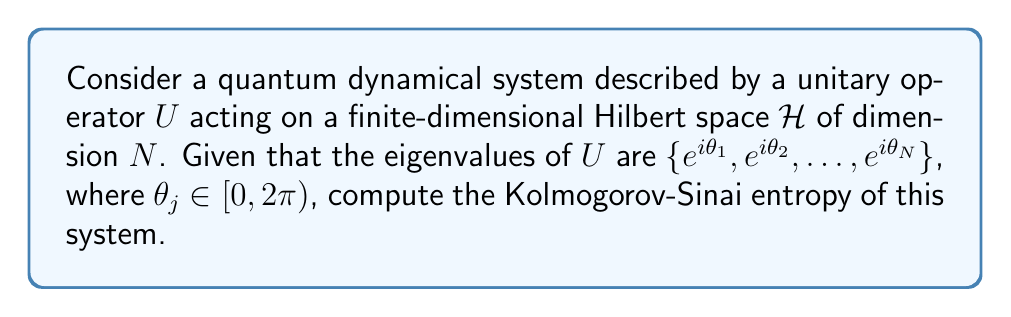Could you help me with this problem? To compute the Kolmogorov-Sinai entropy for this quantum dynamical system, we'll follow these steps:

1) In quantum systems, the Kolmogorov-Sinai entropy is related to the von Neumann entropy rate of the system.

2) For a unitary quantum evolution, the von Neumann entropy of the system remains constant over time. Therefore, the entropy rate (and thus the Kolmogorov-Sinai entropy) is zero for closed quantum systems.

3) This can be understood from the fact that unitary evolution preserves the eigenvalues of the density matrix, and thus the von Neumann entropy.

4) Mathematically, we can express this as:

   $$S(U\rho U^\dagger) = S(\rho)$$

   where $S(\rho) = -\text{Tr}(\rho \log \rho)$ is the von Neumann entropy and $\rho$ is the density matrix of the system.

5) The Kolmogorov-Sinai entropy $h_{KS}$ for this system is defined as:

   $$h_{KS} = \lim_{n\to\infty} \frac{1}{n} S(U^n\rho U^{-n})$$

6) Since $S(U^n\rho U^{-n}) = S(\rho)$ for all $n$, we have:

   $$h_{KS} = \lim_{n\to\infty} \frac{1}{n} S(\rho) = 0$$

Therefore, regardless of the specific eigenvalues of $U$, the Kolmogorov-Sinai entropy of this closed quantum system is zero.
Answer: 0 